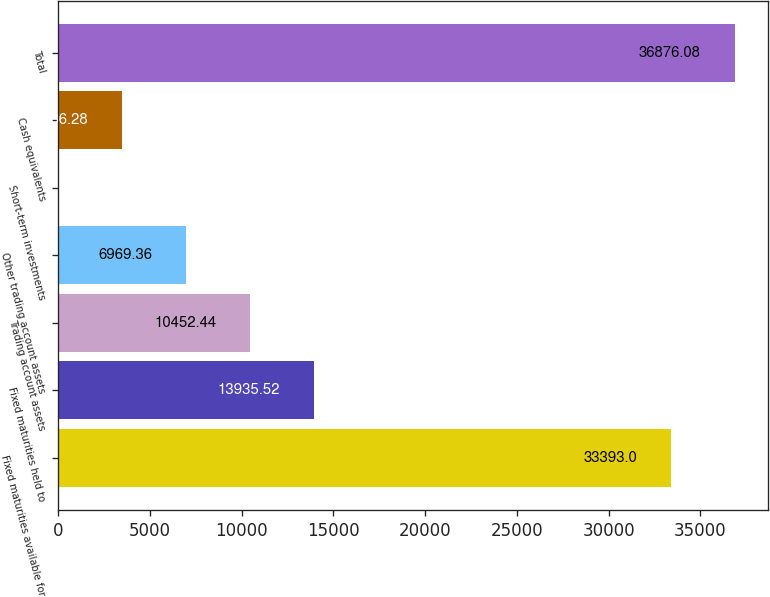Convert chart. <chart><loc_0><loc_0><loc_500><loc_500><bar_chart><fcel>Fixed maturities available for<fcel>Fixed maturities held to<fcel>Trading account assets<fcel>Other trading account assets<fcel>Short-term investments<fcel>Cash equivalents<fcel>Total<nl><fcel>33393<fcel>13935.5<fcel>10452.4<fcel>6969.36<fcel>3.2<fcel>3486.28<fcel>36876.1<nl></chart> 